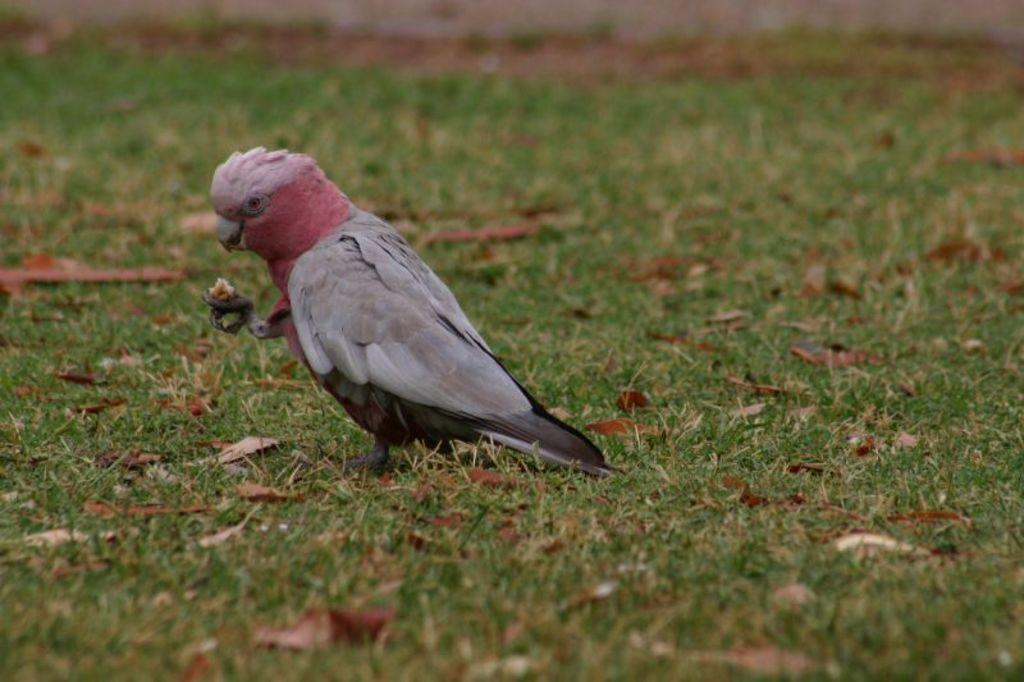What type of animal is in the image? There is a bird in the image. What colors can be seen on the bird? The bird has gray and red colors. What type of vegetation is in the image? There is grass in the image. What color is the grass? The grass is green. Can you hear the bird whistling in the image? There is no sound present in the image, so it is not possible to determine if the bird is whistling. Is there any blood visible on the bird in the image? There is no blood visible on the bird in the image. 